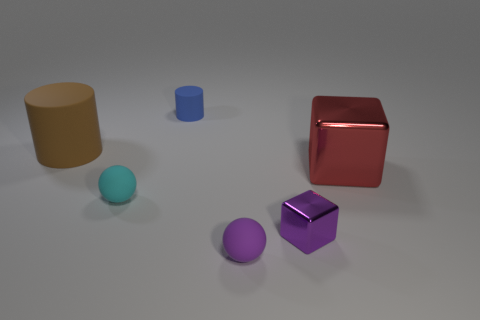There is a big thing behind the red block; what is its shape?
Provide a short and direct response. Cylinder. The big metallic cube is what color?
Your response must be concise. Red. What number of other objects are there of the same size as the blue cylinder?
Give a very brief answer. 3. The cube that is in front of the tiny rubber ball that is on the left side of the small cylinder is made of what material?
Offer a terse response. Metal. Do the cyan rubber thing and the brown rubber object behind the cyan thing have the same size?
Offer a terse response. No. Are there any small things of the same color as the small cube?
Give a very brief answer. Yes. What number of large things are either blue things or blocks?
Provide a succinct answer. 1. How many large metal cylinders are there?
Provide a short and direct response. 0. There is a tiny thing behind the large red shiny block; what material is it?
Your answer should be very brief. Rubber. Are there any cylinders on the left side of the tiny purple shiny thing?
Your answer should be very brief. Yes. 